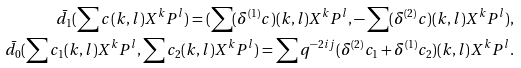Convert formula to latex. <formula><loc_0><loc_0><loc_500><loc_500>\bar { d } _ { 1 } ( \sum c ( k , l ) X ^ { k } P ^ { l } ) = ( \sum ( \delta ^ { ( 1 ) } c ) ( k , l ) X ^ { k } P ^ { l } , - \sum ( \delta ^ { ( 2 ) } c ) ( k , l ) X ^ { k } P ^ { l } ) , \\ \bar { d } _ { 0 } ( \sum c _ { 1 } ( k , l ) X ^ { k } P ^ { l } , \sum c _ { 2 } ( k , l ) X ^ { k } P ^ { l } ) = \sum q ^ { - 2 i j } ( \delta ^ { ( 2 ) } c _ { 1 } + \delta ^ { ( 1 ) } c _ { 2 } ) ( k , l ) X ^ { k } P ^ { l } .</formula> 